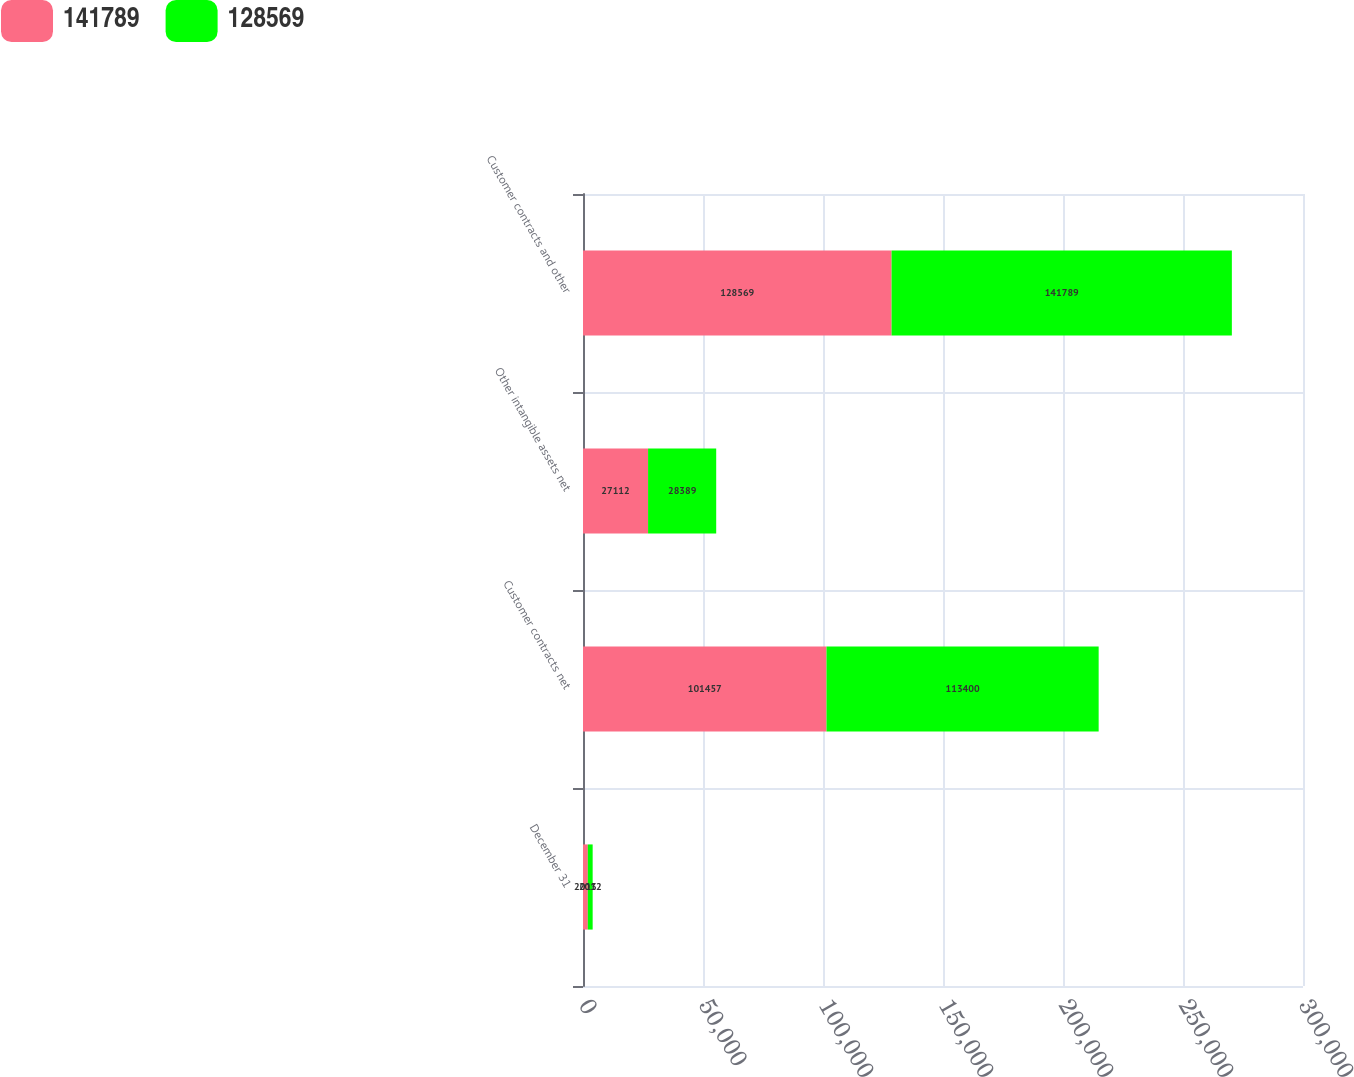Convert chart. <chart><loc_0><loc_0><loc_500><loc_500><stacked_bar_chart><ecel><fcel>December 31<fcel>Customer contracts net<fcel>Other intangible assets net<fcel>Customer contracts and other<nl><fcel>141789<fcel>2013<fcel>101457<fcel>27112<fcel>128569<nl><fcel>128569<fcel>2012<fcel>113400<fcel>28389<fcel>141789<nl></chart> 